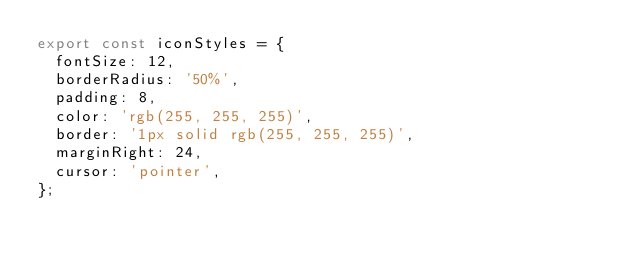<code> <loc_0><loc_0><loc_500><loc_500><_JavaScript_>export const iconStyles = {
  fontSize: 12,
  borderRadius: '50%',
  padding: 8,
  color: 'rgb(255, 255, 255)',
  border: '1px solid rgb(255, 255, 255)',
  marginRight: 24,
  cursor: 'pointer',
};
</code> 